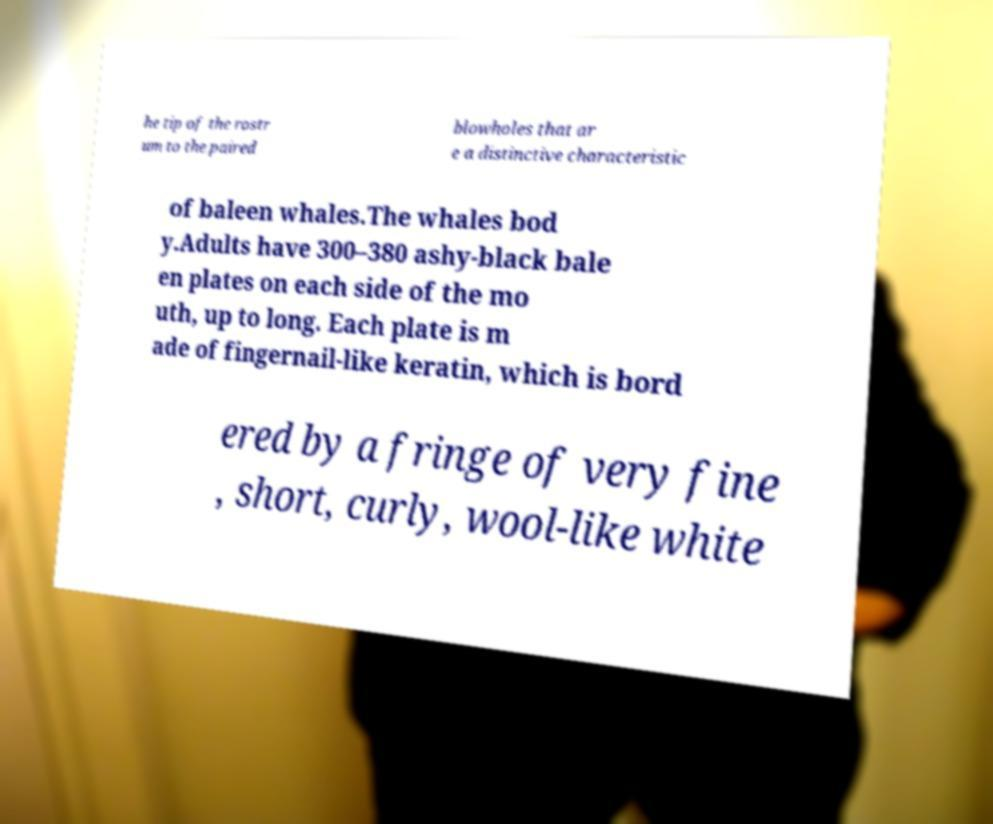Please read and relay the text visible in this image. What does it say? he tip of the rostr um to the paired blowholes that ar e a distinctive characteristic of baleen whales.The whales bod y.Adults have 300–380 ashy-black bale en plates on each side of the mo uth, up to long. Each plate is m ade of fingernail-like keratin, which is bord ered by a fringe of very fine , short, curly, wool-like white 